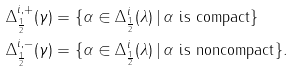Convert formula to latex. <formula><loc_0><loc_0><loc_500><loc_500>\Delta _ { \frac { 1 } { 2 } } ^ { i , + } ( \gamma ) & = \{ \alpha \in \Delta _ { \frac { 1 } { 2 } } ^ { i } ( \lambda ) \, | \, \alpha \text { is  compact} \} \\ \Delta _ { \frac { 1 } { 2 } } ^ { i , - } ( \gamma ) & = \{ \alpha \in \Delta _ { \frac { 1 } { 2 } } ^ { i } ( \lambda ) \, | \, \alpha \text { is  noncompact} \} .</formula> 